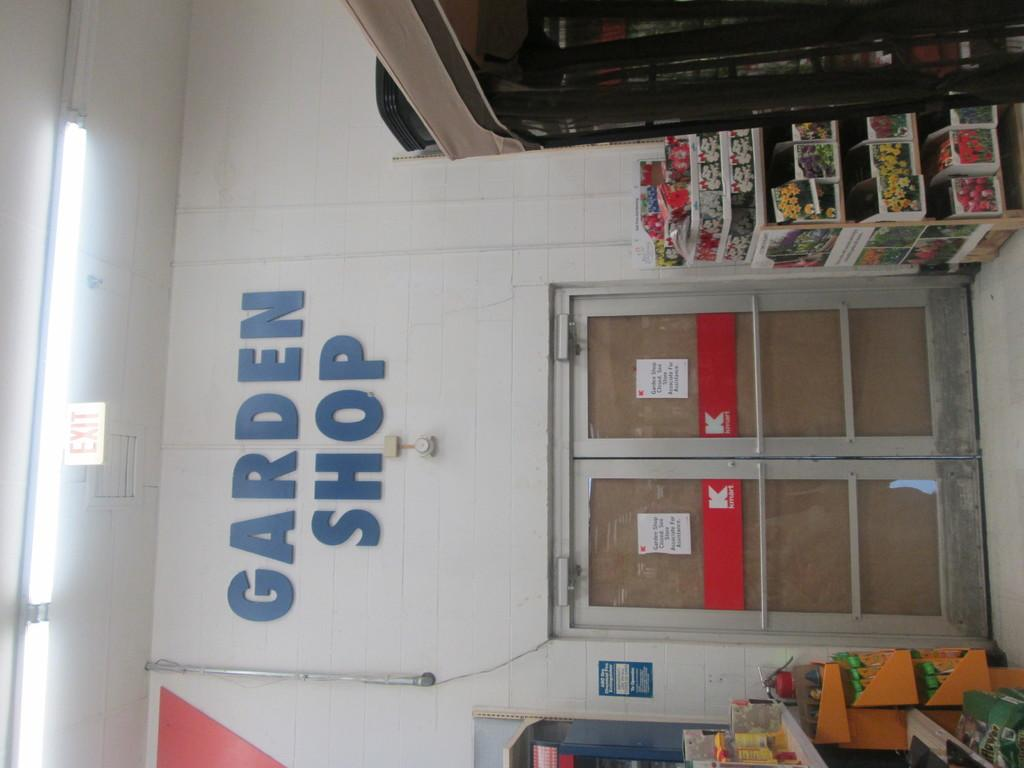<image>
Share a concise interpretation of the image provided. two double doors to a k mart with the logo garden shop on top of the doors. 